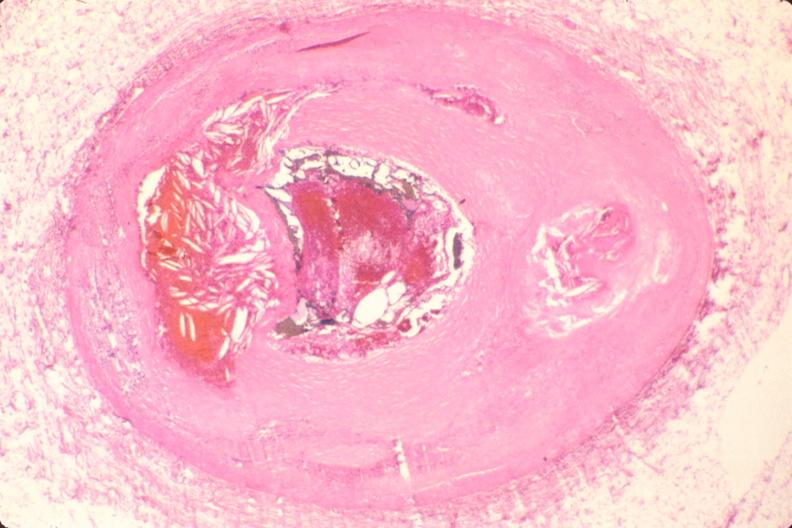s stillborn macerated present?
Answer the question using a single word or phrase. No 